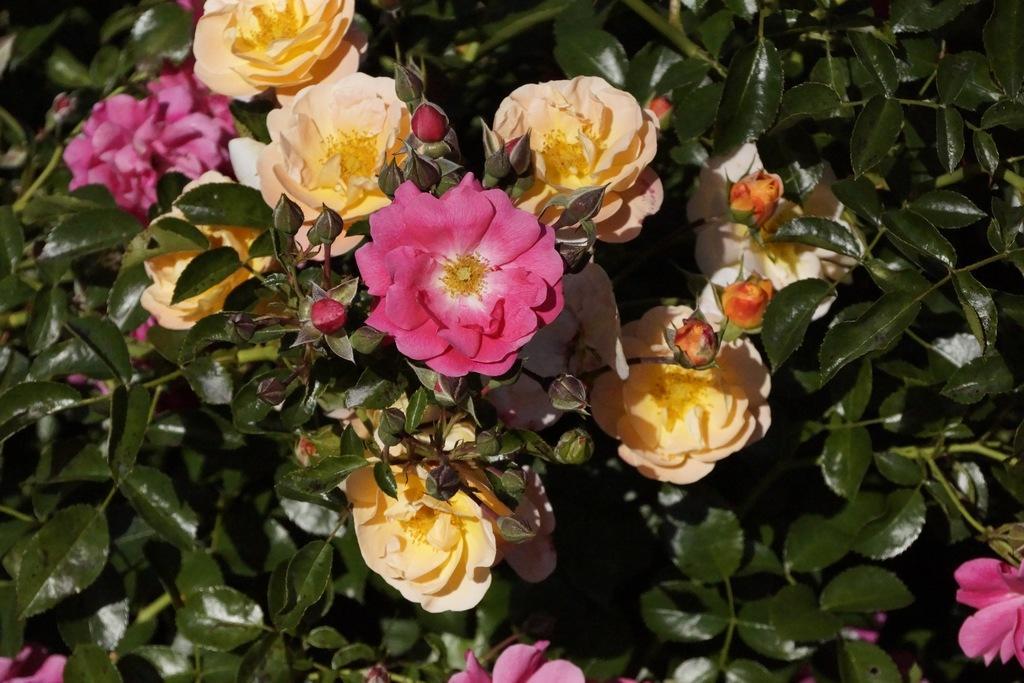In one or two sentences, can you explain what this image depicts? In this picture we can see a few colorful flowers, buds and some green leaves. 